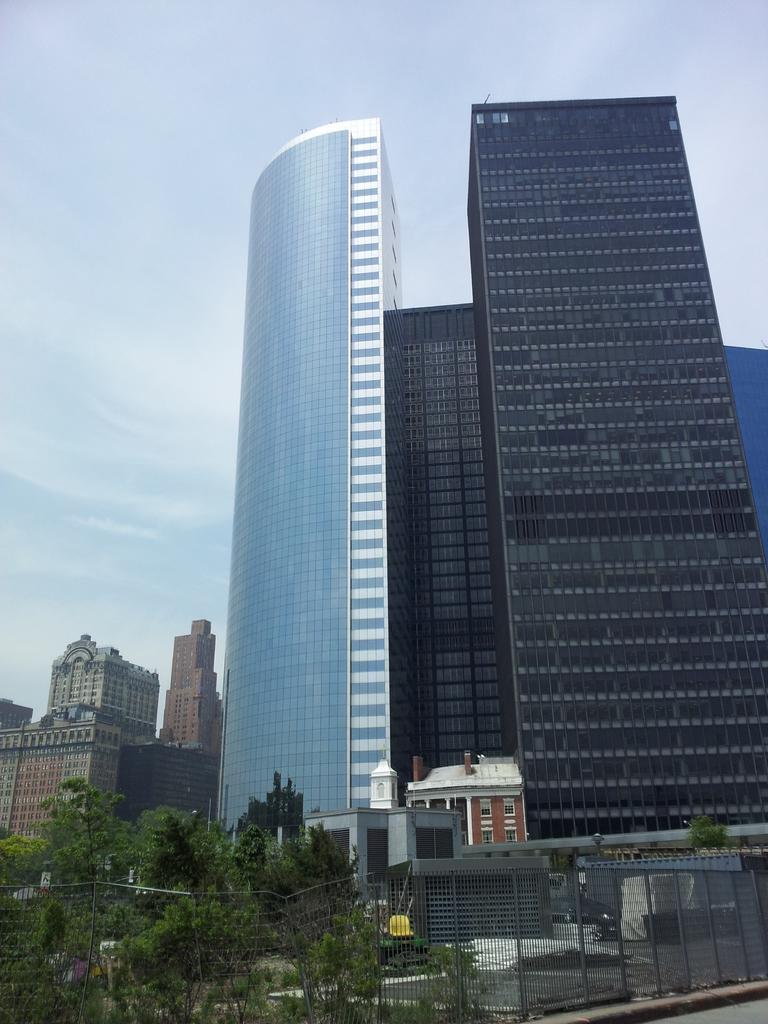Describe this image in one or two sentences. In this image we can see buildings, trees. At the top of the image there is sky. 